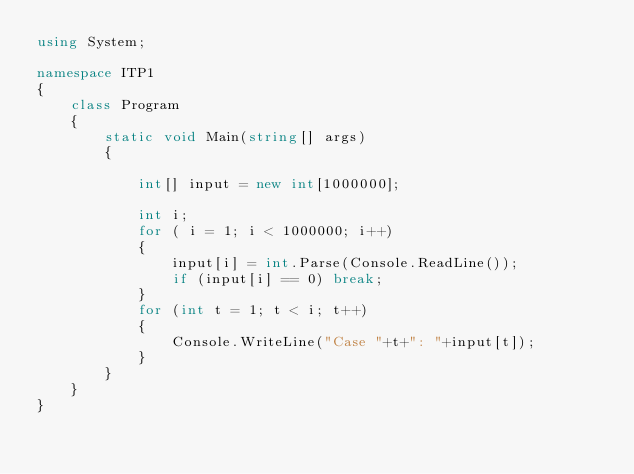<code> <loc_0><loc_0><loc_500><loc_500><_C#_>using System;

namespace ITP1
{
    class Program
    {
        static void Main(string[] args)
        {
            
            int[] input = new int[1000000];

            int i;
            for ( i = 1; i < 1000000; i++)
            {
                input[i] = int.Parse(Console.ReadLine());
                if (input[i] == 0) break;
            }
            for (int t = 1; t < i; t++)
            {
                Console.WriteLine("Case "+t+": "+input[t]);
            }
        }
    }
}</code> 